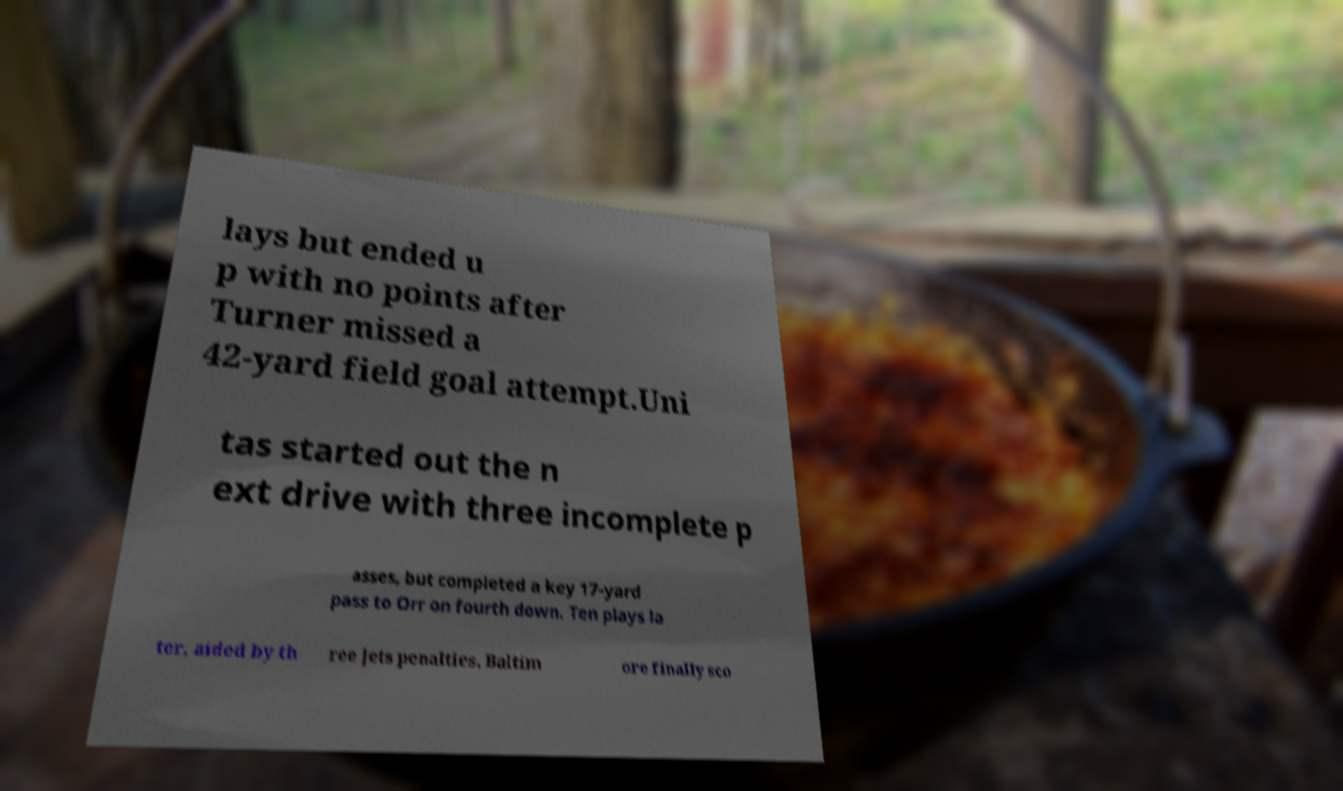Could you extract and type out the text from this image? lays but ended u p with no points after Turner missed a 42-yard field goal attempt.Uni tas started out the n ext drive with three incomplete p asses, but completed a key 17-yard pass to Orr on fourth down. Ten plays la ter, aided by th ree Jets penalties, Baltim ore finally sco 